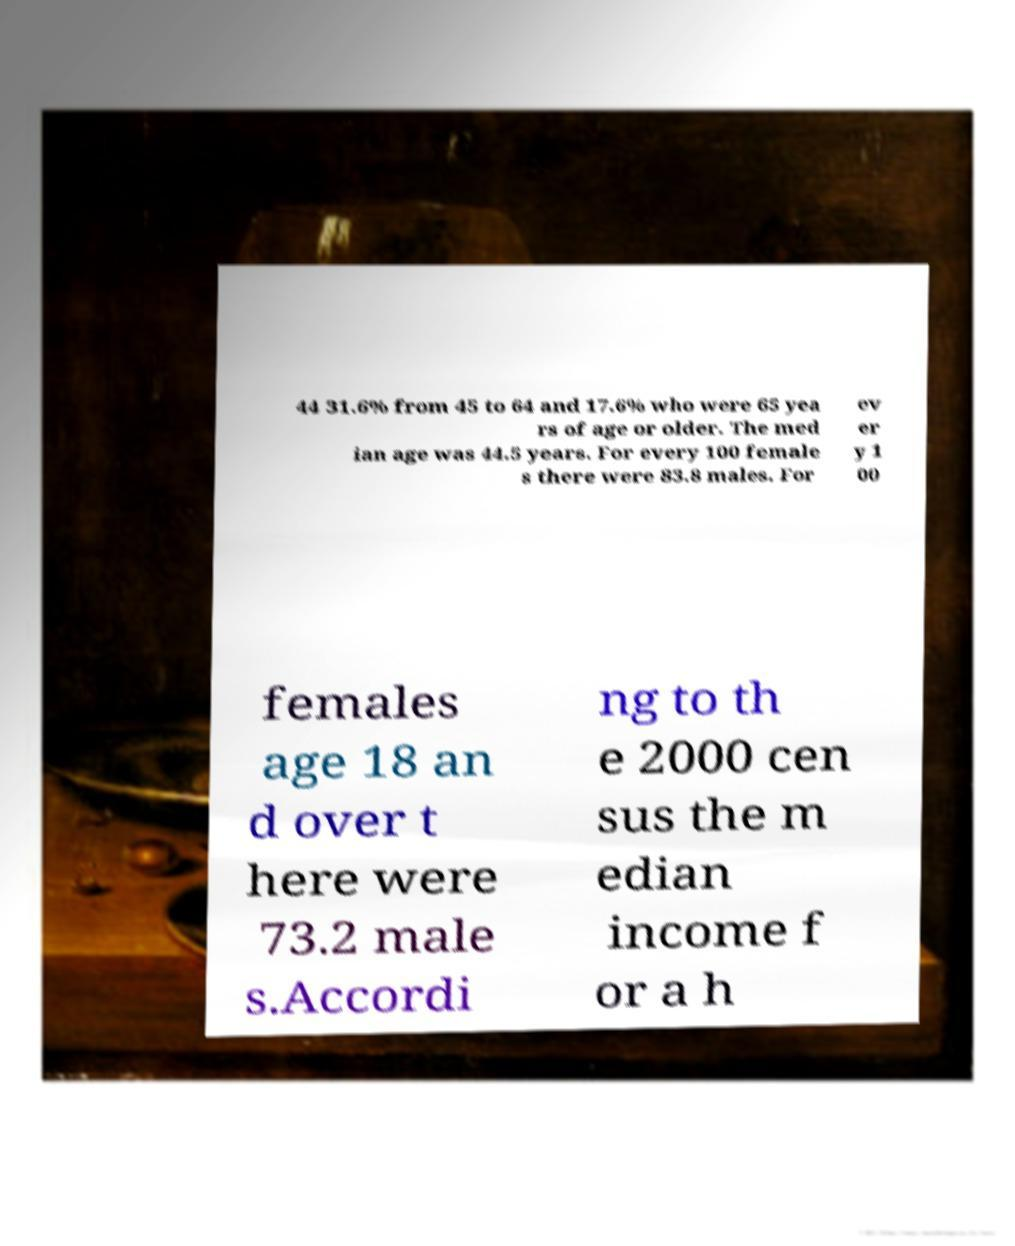There's text embedded in this image that I need extracted. Can you transcribe it verbatim? 44 31.6% from 45 to 64 and 17.6% who were 65 yea rs of age or older. The med ian age was 44.5 years. For every 100 female s there were 83.8 males. For ev er y 1 00 females age 18 an d over t here were 73.2 male s.Accordi ng to th e 2000 cen sus the m edian income f or a h 